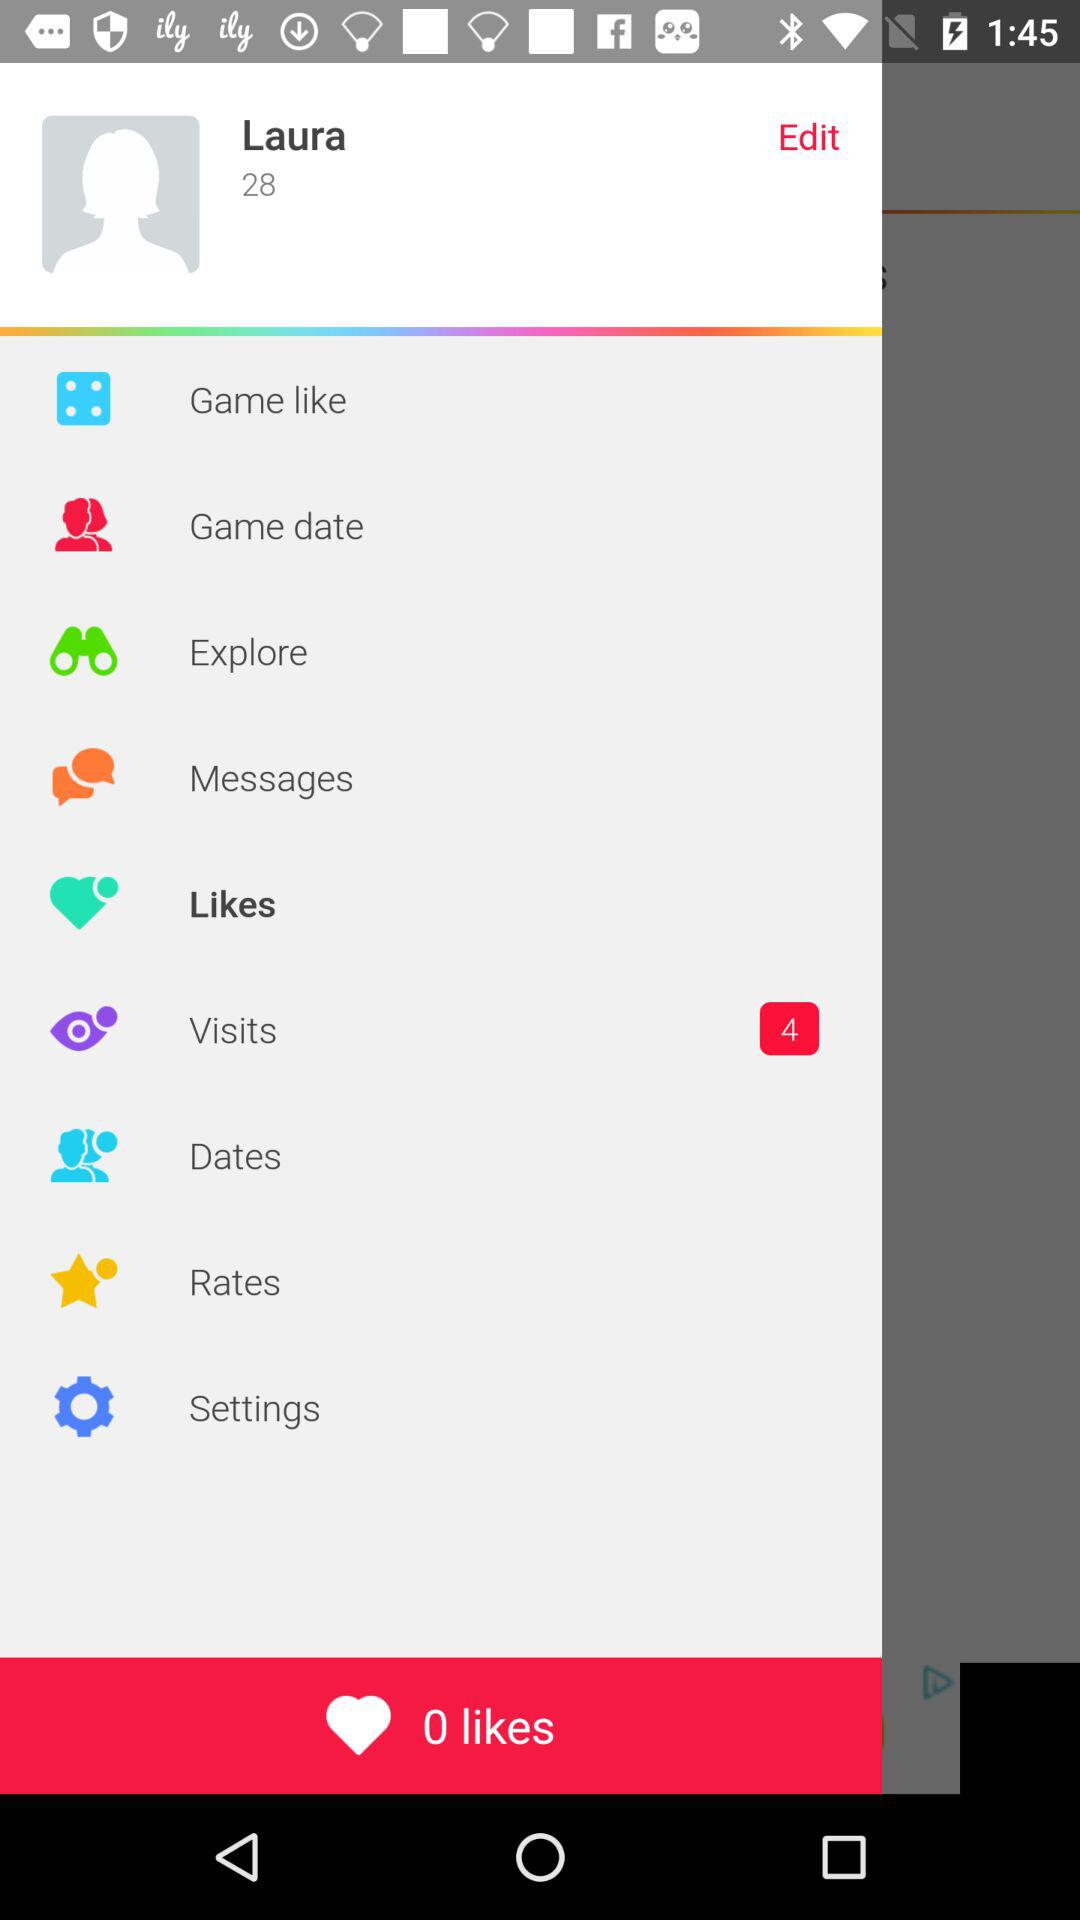Where does "Laura" live?
When the provided information is insufficient, respond with <no answer>. <no answer> 